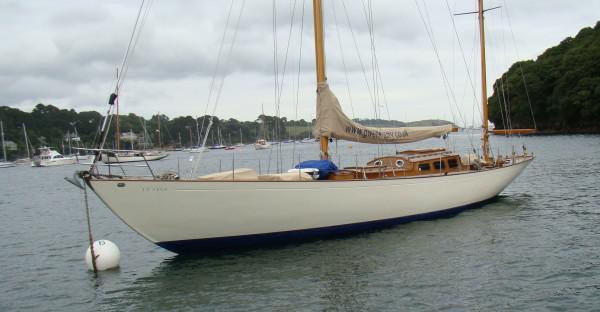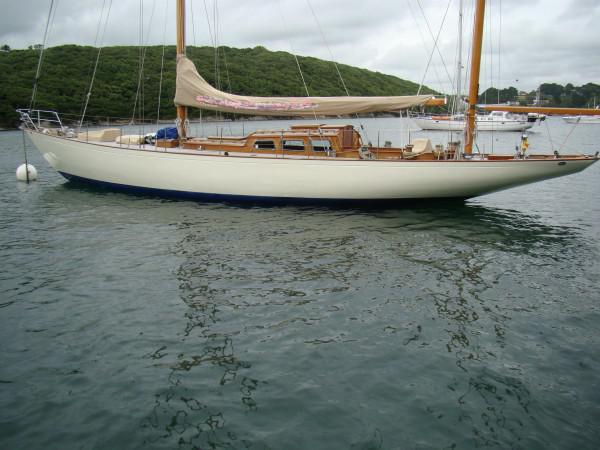The first image is the image on the left, the second image is the image on the right. For the images displayed, is the sentence "In at least one image there is a boat with 3 sails raised" factually correct? Answer yes or no. No. The first image is the image on the left, the second image is the image on the right. Analyze the images presented: Is the assertion "One image in the pair shows the boat's sails up, the other image shows the sails folded down." valid? Answer yes or no. No. 